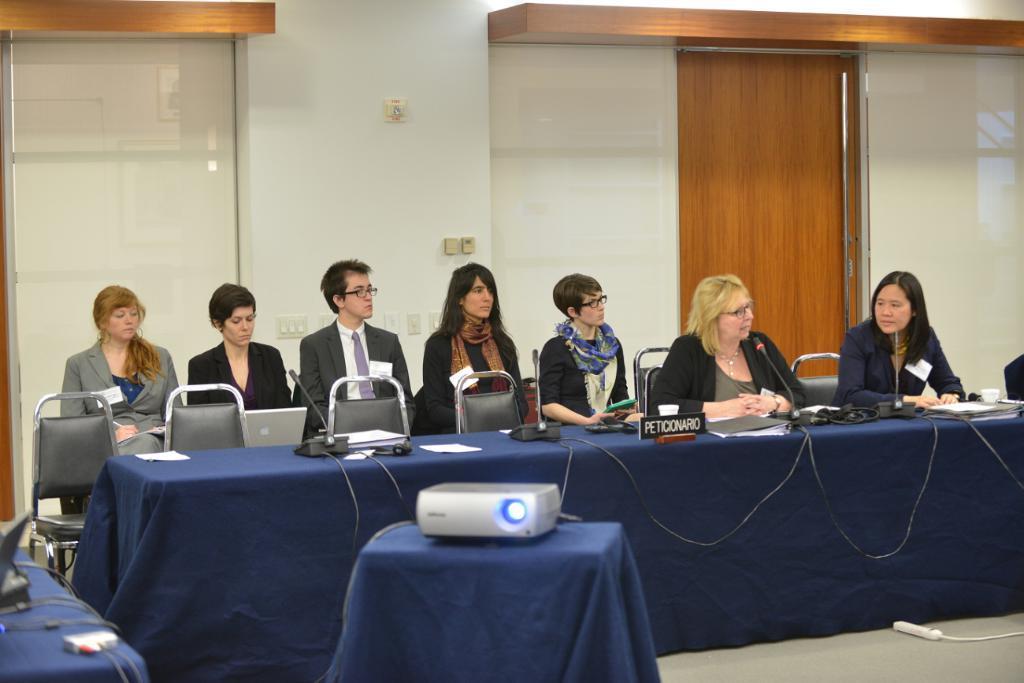Describe this image in one or two sentences. In this image we can see a few people who are sitting on a chair. There is a woman here is speaking on a microphone. This is a table which is covered with a blue cloth, where cellphones are kept on it. Here we can see a projector which is placed on this table. This is a door. 